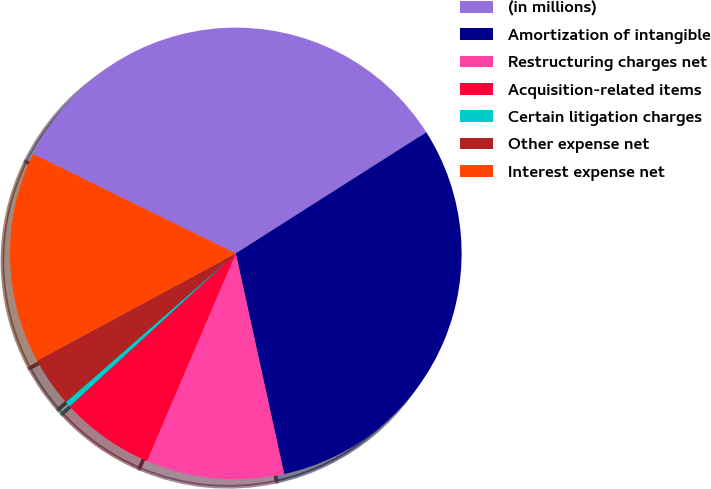Convert chart. <chart><loc_0><loc_0><loc_500><loc_500><pie_chart><fcel>(in millions)<fcel>Amortization of intangible<fcel>Restructuring charges net<fcel>Acquisition-related items<fcel>Certain litigation charges<fcel>Other expense net<fcel>Interest expense net<nl><fcel>33.73%<fcel>30.58%<fcel>9.87%<fcel>6.72%<fcel>0.41%<fcel>3.56%<fcel>15.13%<nl></chart> 